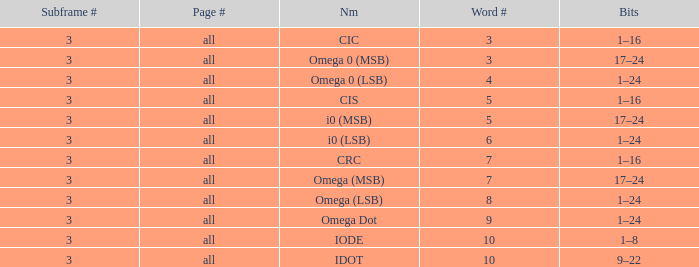What is the word count that is named omega dot? 9.0. 